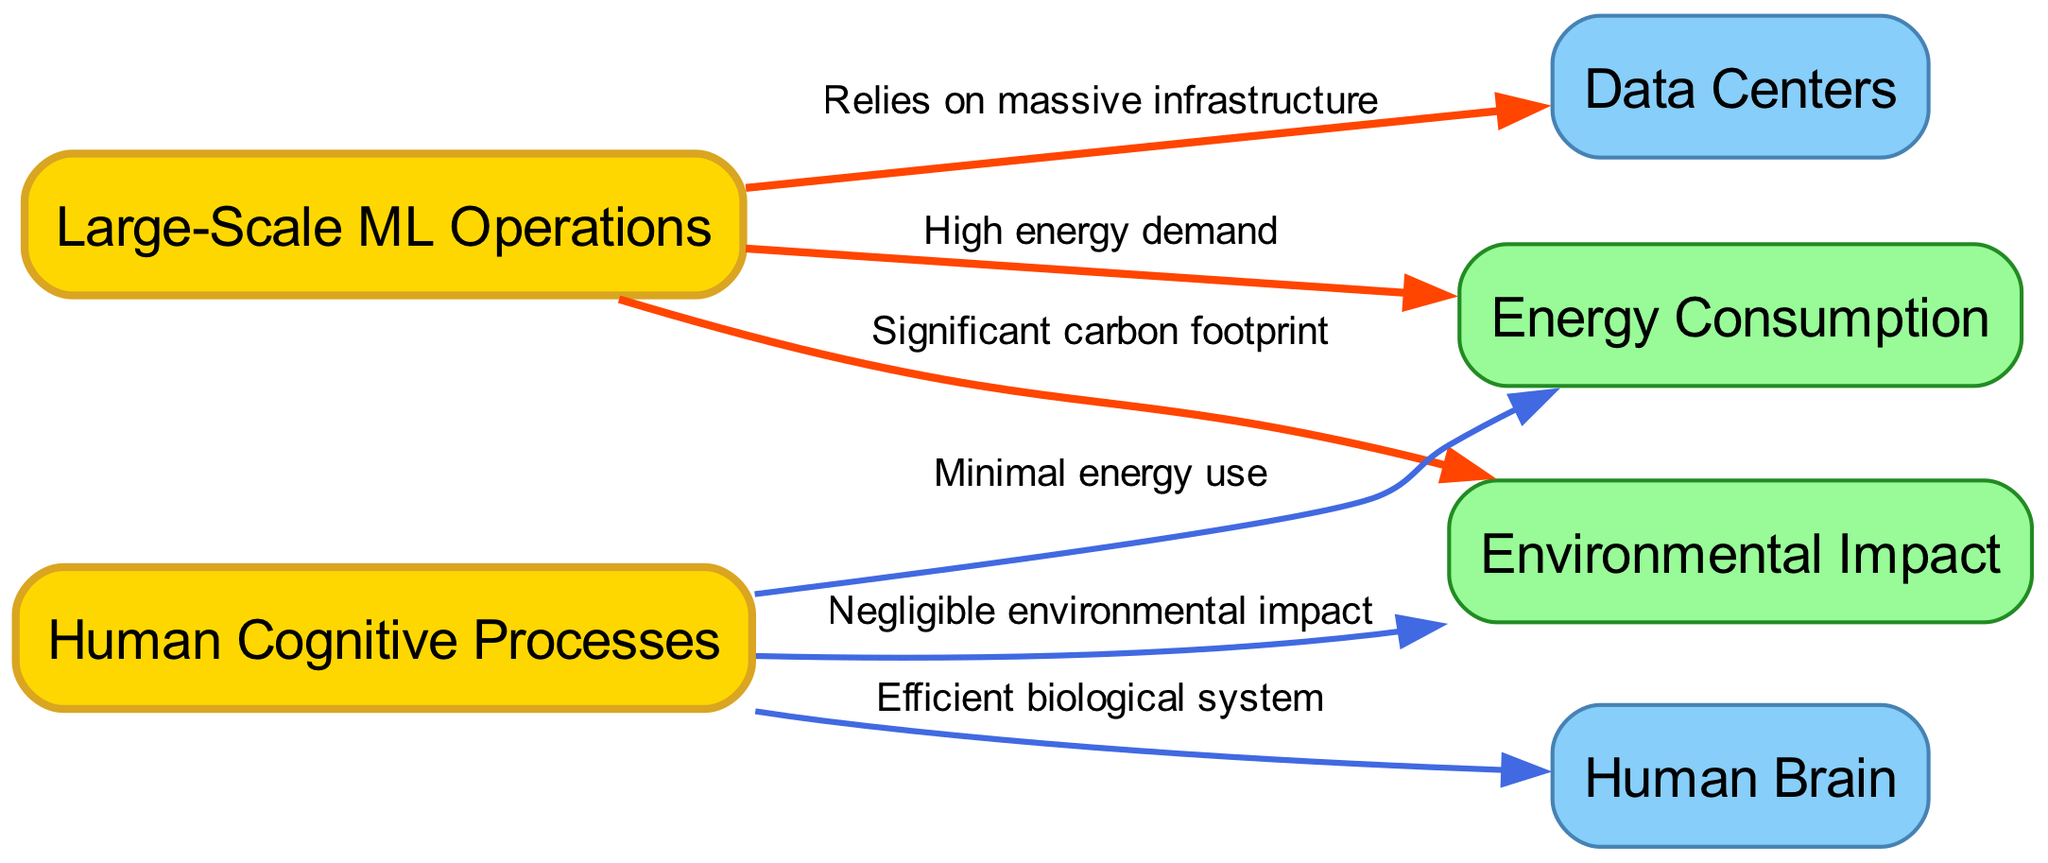What is the energy consumption of large-scale ML operations? The diagram indicates that large-scale machine learning operations have "High energy demand," as described by the edge connecting them to the energy consumption node.
Answer: High energy demand What is the environmental impact of human cognitive processes? The diagram shows that human cognitive processes have a "Negligible environmental impact," as mentioned by the edge that connects human cognitive processes to the environmental impact node.
Answer: Negligible environmental impact How many nodes are represented in the diagram? By counting the unique entities listed in the nodes section, there are a total of six nodes represented in the diagram.
Answer: 6 What are the two systems mentioned that rely on significant infrastructure? According to the diagram, it shows that "Large-Scale ML Operations" relies on "massive infrastructure," highlighting the contrasting requirements of the systems.
Answer: Large-Scale ML Operations and Data Centers Which system uses minimal energy? The edge from the "Human Cognitive Processes" to the "Energy Consumption" node indicates that human cognitive processes use "Minimal energy use."
Answer: Minimal energy use What does the large-scale ML operations create regarding environmental effects? The diagram specifies that large-scale ML operations have a "Significant carbon footprint," which is indicated by the connection to the environmental impact node.
Answer: Significant carbon footprint How does the human brain operate in relation to energy? The edge connecting "Human Cognitive Processes" to the "Human Brain" states that the human brain is an "Efficient biological system," indicating its favorable energy performance.
Answer: Efficient biological system What is the relationship of data centers to large-scale ML operations? The diagram illustrates that large-scale ML operations "Relies on massive infrastructure," specifically indicating the importance of data centers in this relationship.
Answer: Relies on massive infrastructure What type of environmental impact do large-scale ML operations create? The edge from large-scale ML operations to environmental impact states that they have a "Significant carbon footprint," clearly indicating their negative influence on the environment.
Answer: Significant carbon footprint 